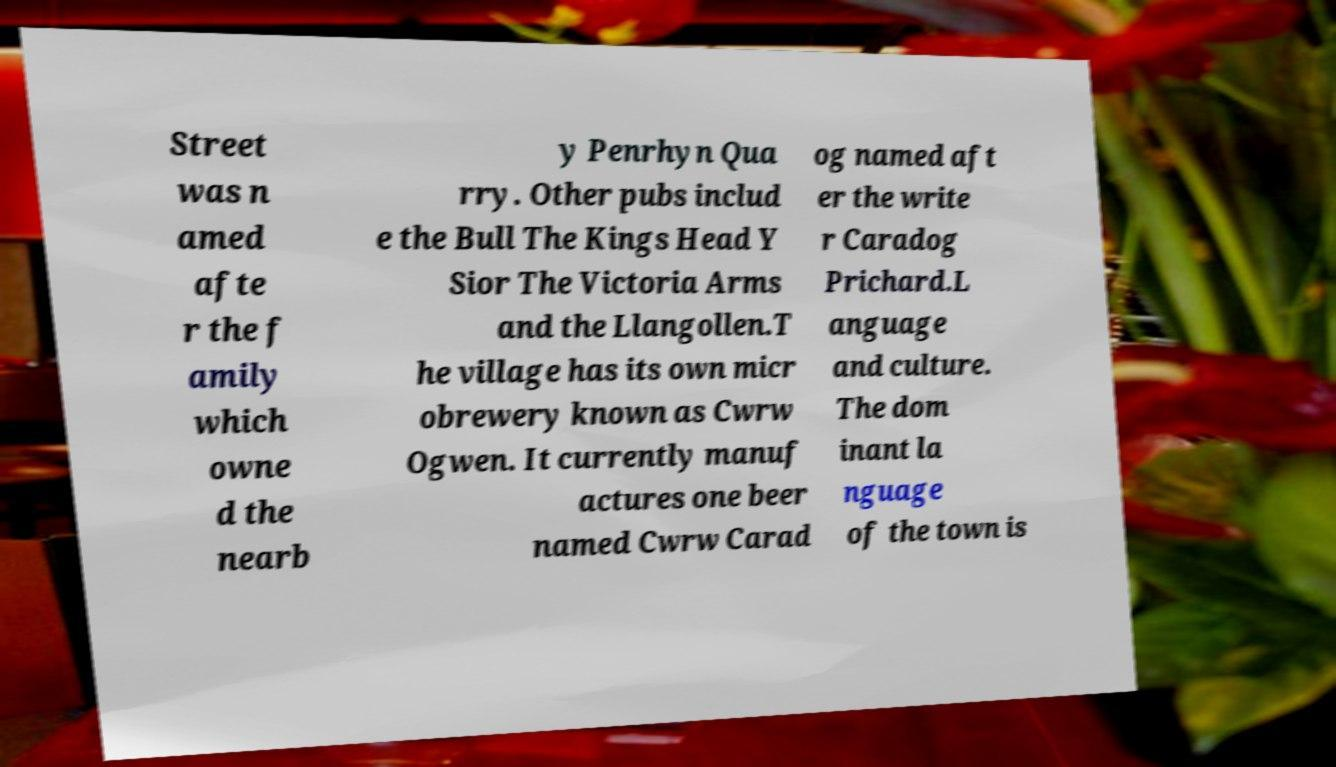Could you extract and type out the text from this image? Street was n amed afte r the f amily which owne d the nearb y Penrhyn Qua rry. Other pubs includ e the Bull The Kings Head Y Sior The Victoria Arms and the Llangollen.T he village has its own micr obrewery known as Cwrw Ogwen. It currently manuf actures one beer named Cwrw Carad og named aft er the write r Caradog Prichard.L anguage and culture. The dom inant la nguage of the town is 